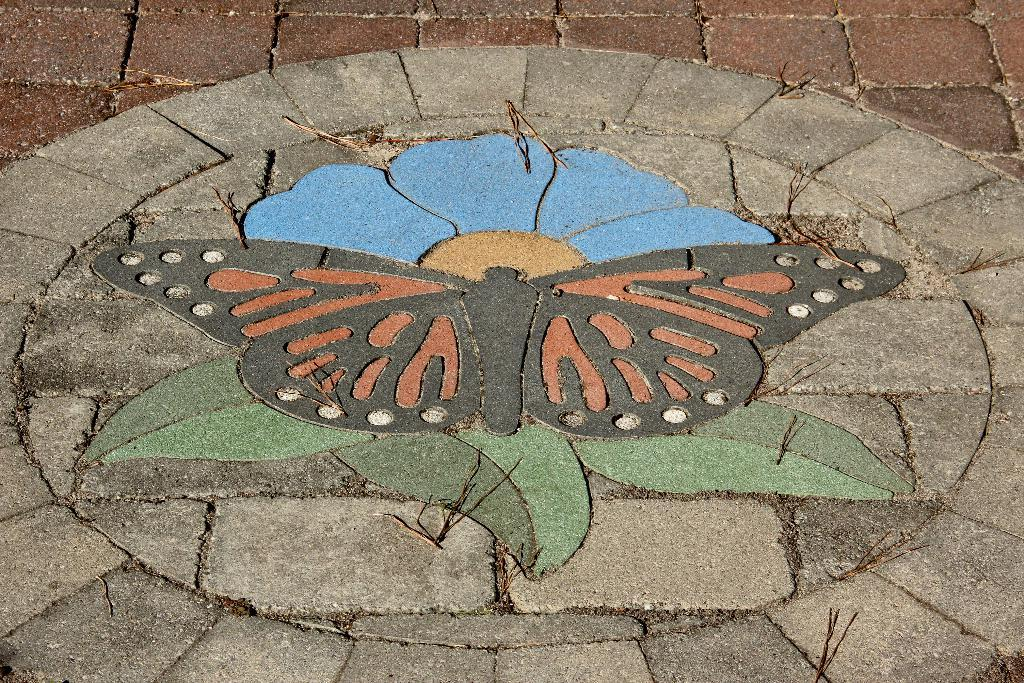What is depicted in the painting that is visible in the image? There is a painting of a butterfly in the image. What other object can be seen on the ground in the image? There is a flower on the ground in the image. What material is the ground made of in the image? The ground is made of granite stones. What type of worm can be seen crawling on the painting in the image? There is no worm present in the image; it features a painting of a butterfly and a flower on the ground. What kind of music can be heard playing in the background of the image? There is no music present in the image; it only shows a painting of a butterfly and a flower on the ground. 